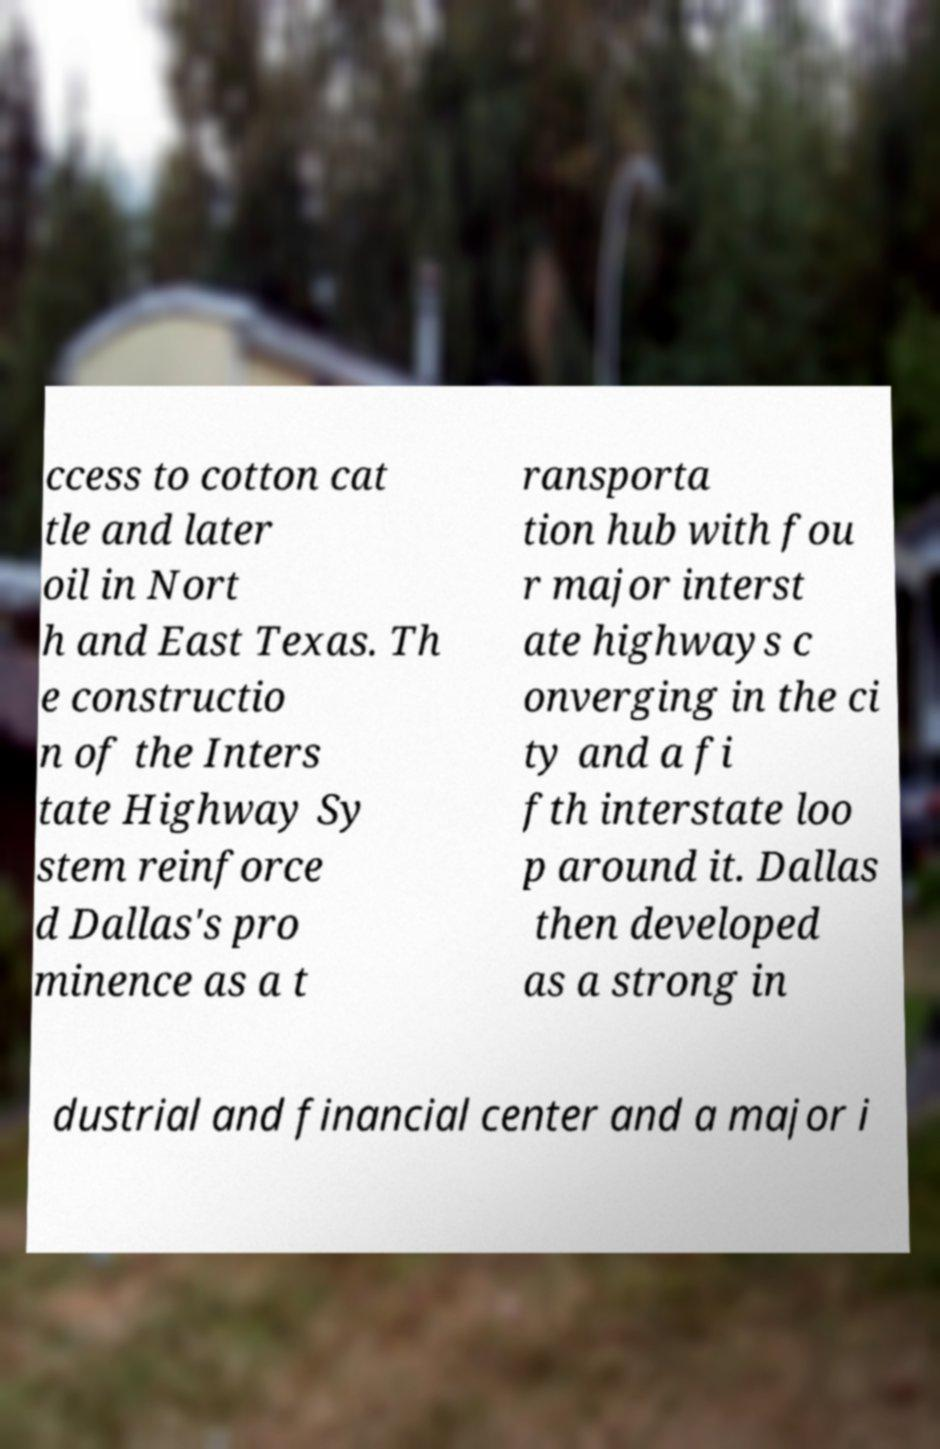I need the written content from this picture converted into text. Can you do that? ccess to cotton cat tle and later oil in Nort h and East Texas. Th e constructio n of the Inters tate Highway Sy stem reinforce d Dallas's pro minence as a t ransporta tion hub with fou r major interst ate highways c onverging in the ci ty and a fi fth interstate loo p around it. Dallas then developed as a strong in dustrial and financial center and a major i 